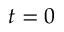Convert formula to latex. <formula><loc_0><loc_0><loc_500><loc_500>t = 0</formula> 